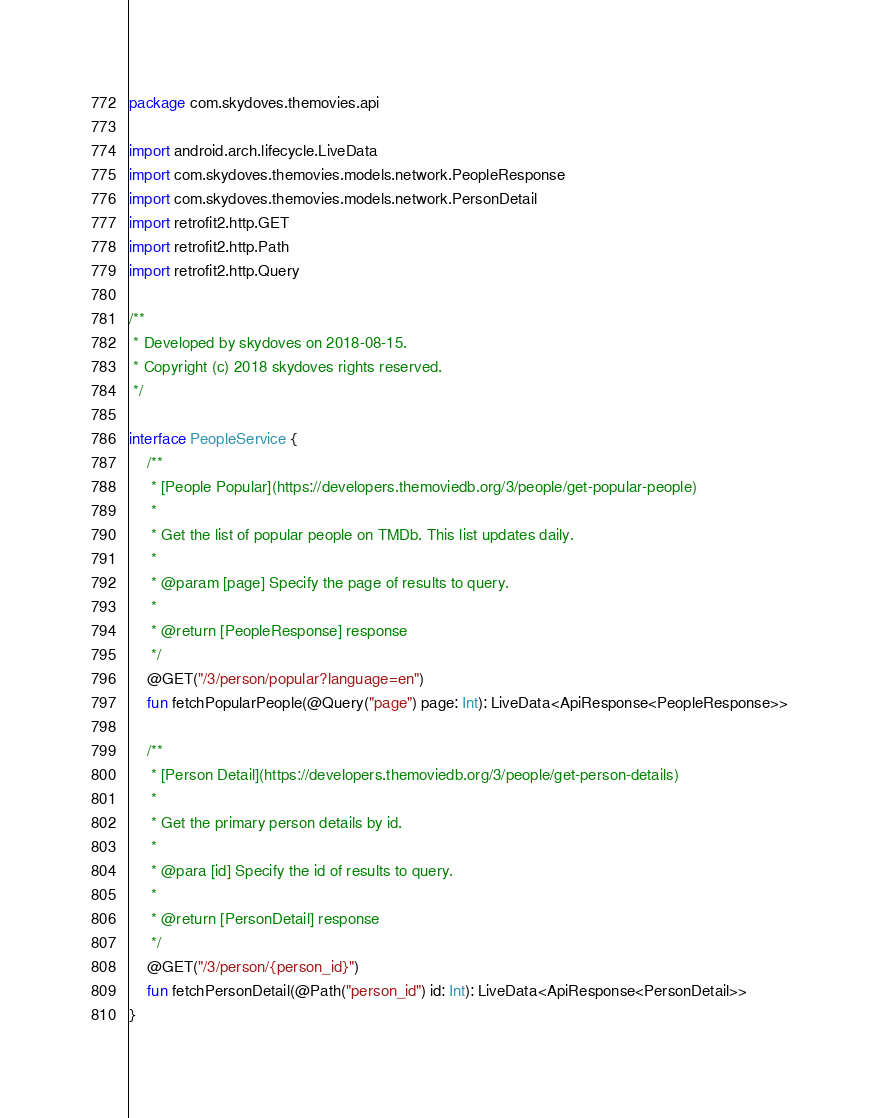<code> <loc_0><loc_0><loc_500><loc_500><_Kotlin_>package com.skydoves.themovies.api

import android.arch.lifecycle.LiveData
import com.skydoves.themovies.models.network.PeopleResponse
import com.skydoves.themovies.models.network.PersonDetail
import retrofit2.http.GET
import retrofit2.http.Path
import retrofit2.http.Query

/**
 * Developed by skydoves on 2018-08-15.
 * Copyright (c) 2018 skydoves rights reserved.
 */

interface PeopleService {
    /**
     * [People Popular](https://developers.themoviedb.org/3/people/get-popular-people)
     *
     * Get the list of popular people on TMDb. This list updates daily.
     *
     * @param [page] Specify the page of results to query.
     *
     * @return [PeopleResponse] response
     */
    @GET("/3/person/popular?language=en")
    fun fetchPopularPeople(@Query("page") page: Int): LiveData<ApiResponse<PeopleResponse>>

    /**
     * [Person Detail](https://developers.themoviedb.org/3/people/get-person-details)
     *
     * Get the primary person details by id.
     *
     * @para [id] Specify the id of results to query.
     *
     * @return [PersonDetail] response
     */
    @GET("/3/person/{person_id}")
    fun fetchPersonDetail(@Path("person_id") id: Int): LiveData<ApiResponse<PersonDetail>>
}
</code> 